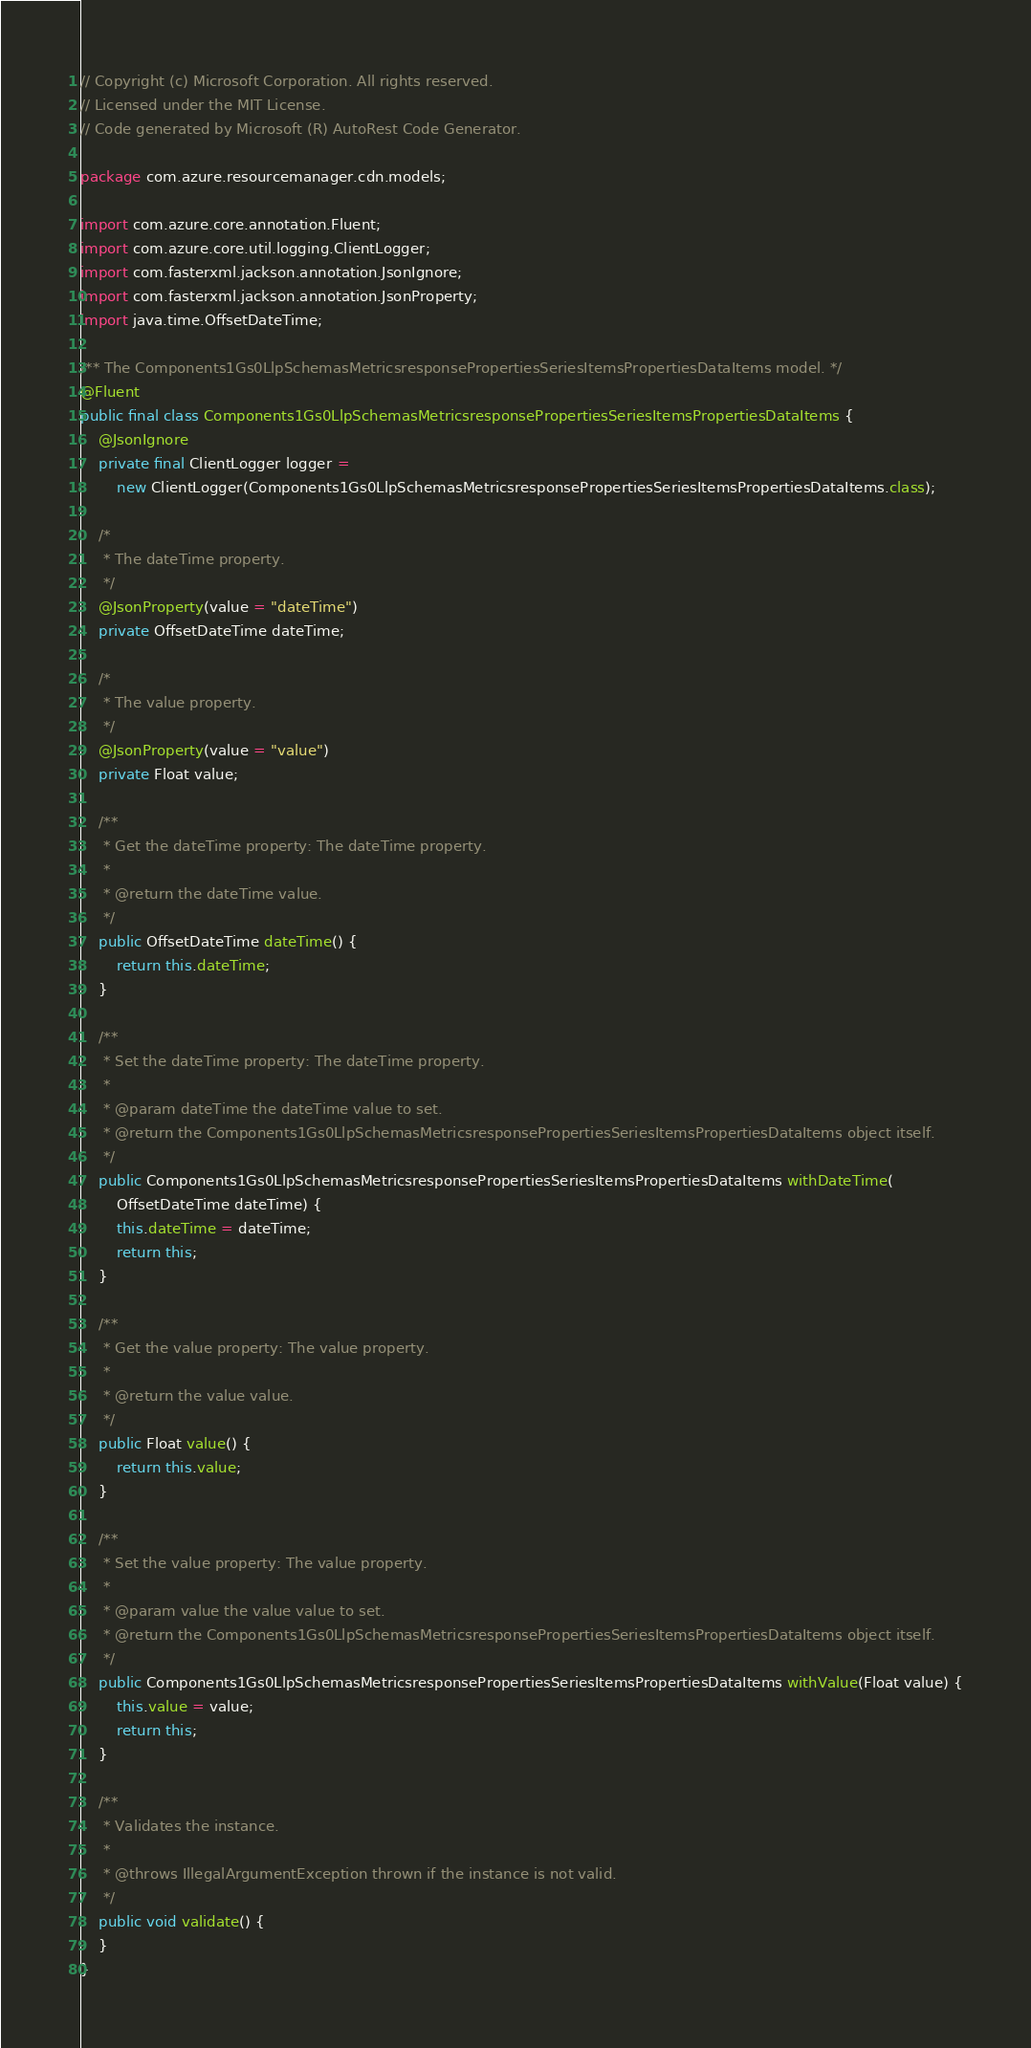Convert code to text. <code><loc_0><loc_0><loc_500><loc_500><_Java_>// Copyright (c) Microsoft Corporation. All rights reserved.
// Licensed under the MIT License.
// Code generated by Microsoft (R) AutoRest Code Generator.

package com.azure.resourcemanager.cdn.models;

import com.azure.core.annotation.Fluent;
import com.azure.core.util.logging.ClientLogger;
import com.fasterxml.jackson.annotation.JsonIgnore;
import com.fasterxml.jackson.annotation.JsonProperty;
import java.time.OffsetDateTime;

/** The Components1Gs0LlpSchemasMetricsresponsePropertiesSeriesItemsPropertiesDataItems model. */
@Fluent
public final class Components1Gs0LlpSchemasMetricsresponsePropertiesSeriesItemsPropertiesDataItems {
    @JsonIgnore
    private final ClientLogger logger =
        new ClientLogger(Components1Gs0LlpSchemasMetricsresponsePropertiesSeriesItemsPropertiesDataItems.class);

    /*
     * The dateTime property.
     */
    @JsonProperty(value = "dateTime")
    private OffsetDateTime dateTime;

    /*
     * The value property.
     */
    @JsonProperty(value = "value")
    private Float value;

    /**
     * Get the dateTime property: The dateTime property.
     *
     * @return the dateTime value.
     */
    public OffsetDateTime dateTime() {
        return this.dateTime;
    }

    /**
     * Set the dateTime property: The dateTime property.
     *
     * @param dateTime the dateTime value to set.
     * @return the Components1Gs0LlpSchemasMetricsresponsePropertiesSeriesItemsPropertiesDataItems object itself.
     */
    public Components1Gs0LlpSchemasMetricsresponsePropertiesSeriesItemsPropertiesDataItems withDateTime(
        OffsetDateTime dateTime) {
        this.dateTime = dateTime;
        return this;
    }

    /**
     * Get the value property: The value property.
     *
     * @return the value value.
     */
    public Float value() {
        return this.value;
    }

    /**
     * Set the value property: The value property.
     *
     * @param value the value value to set.
     * @return the Components1Gs0LlpSchemasMetricsresponsePropertiesSeriesItemsPropertiesDataItems object itself.
     */
    public Components1Gs0LlpSchemasMetricsresponsePropertiesSeriesItemsPropertiesDataItems withValue(Float value) {
        this.value = value;
        return this;
    }

    /**
     * Validates the instance.
     *
     * @throws IllegalArgumentException thrown if the instance is not valid.
     */
    public void validate() {
    }
}
</code> 